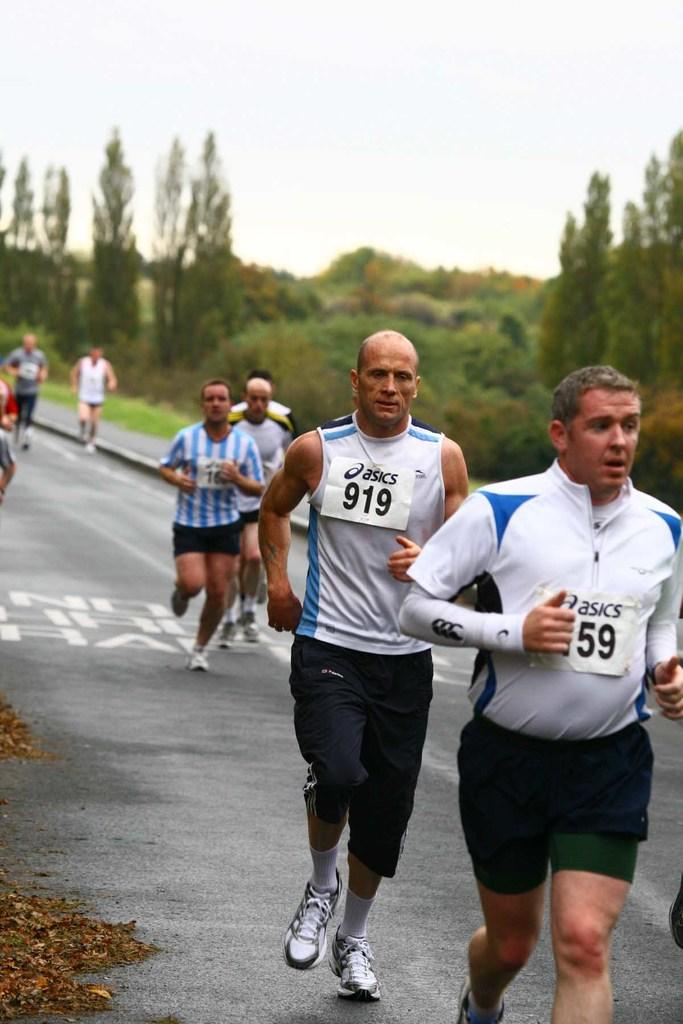What are the people in the image doing? The people in the image are running on the road. What can be seen in the background of the image? There are trees, plants, and the sky visible in the background of the image. What type of dinner is being served in the image? There is no dinner present in the image; it features people running on the road. How can the people in the image be helped to complete their journey? The image does not indicate that the people are on a journey or require help. 